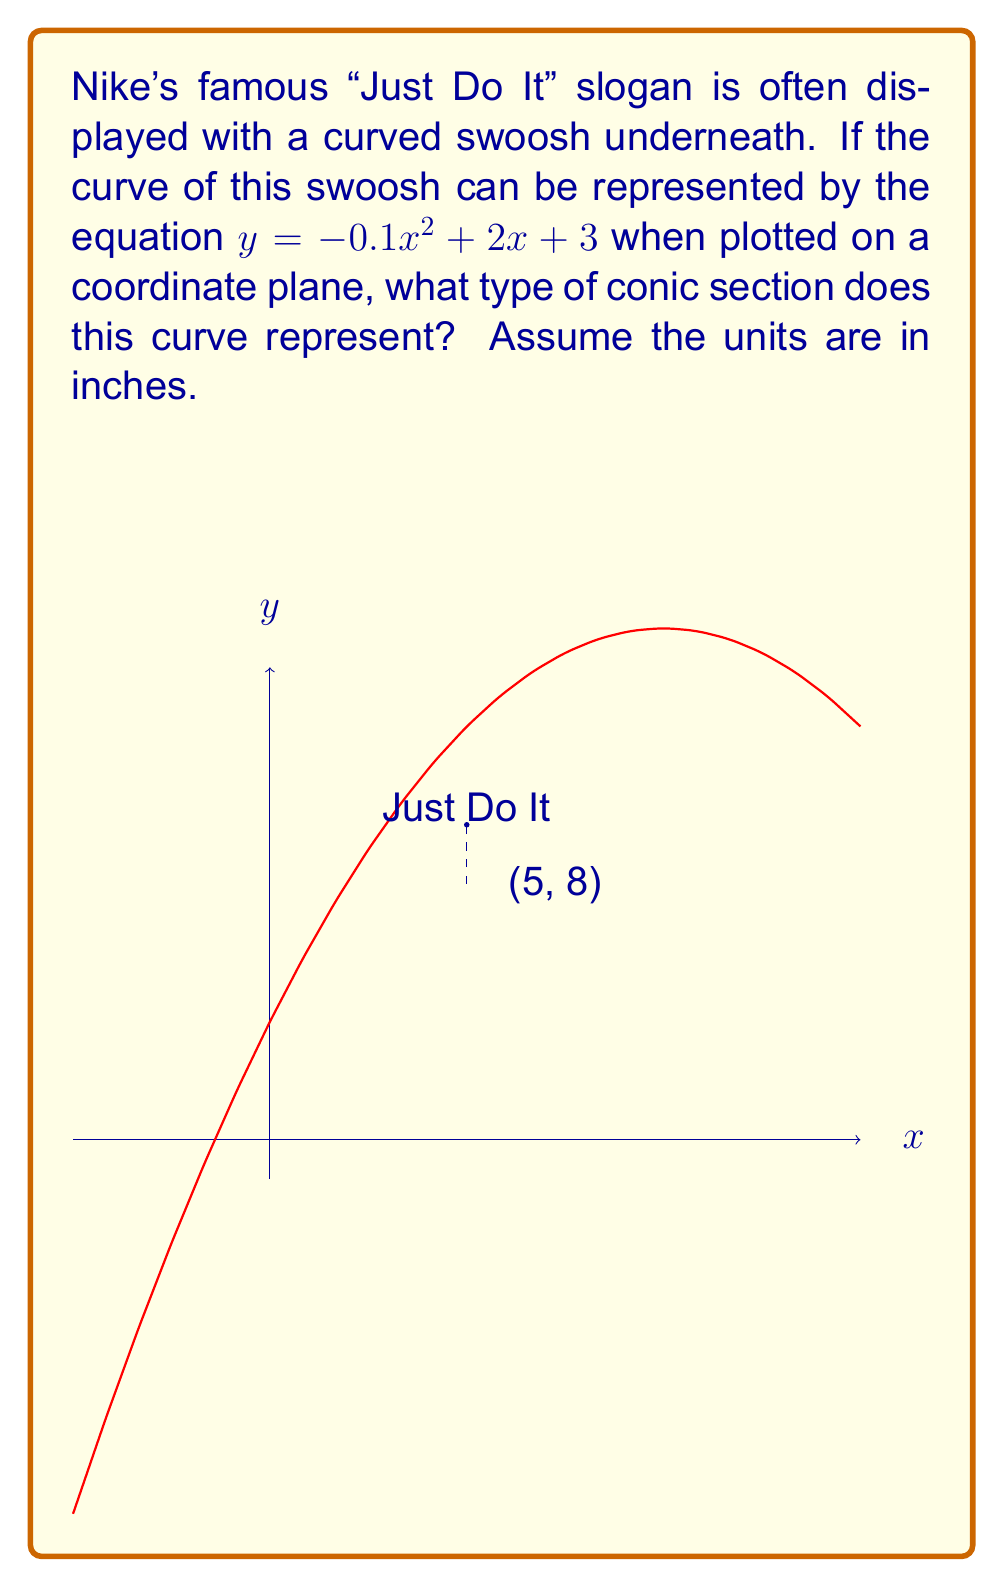What is the answer to this math problem? To identify the type of conic section, we need to analyze the general form of the equation:

$y = -0.1x^2 + 2x + 3$

Let's break this down step-by-step:

1) The general form of a quadratic equation is $y = ax^2 + bx + c$, where:
   $a = -0.1$
   $b = 2$
   $c = 3$

2) In conic sections, when we have an equation in the form $y = ax^2 + bx + c$:
   - If $a > 0$, it's a parabola opening upward
   - If $a < 0$, it's a parabola opening downward
   - If $a = 0$, it's a straight line (degenerate case)

3) In this case, $a = -0.1 < 0$, so we have a parabola opening downward.

4) The vertex form of a parabola is $y = a(x - h)^2 + k$, where $(h, k)$ is the vertex.
   To find the vertex, we can use the formulas:
   $h = -\frac{b}{2a}$ and $k = f(h)$

   $h = -\frac{2}{2(-0.1)} = 10$
   $k = -0.1(10)^2 + 2(10) + 3 = 13$

   So the vertex is at (10, 13).

5) The parabola represents the curve of the swoosh, opening downward, with its peak at (10, 13) inches.

Therefore, the curve of the Nike swoosh in this representation is a parabola, which is a type of conic section.
Answer: Parabola 